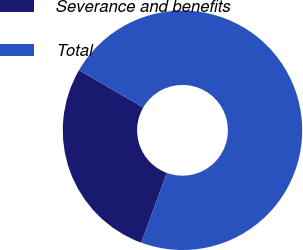Convert chart to OTSL. <chart><loc_0><loc_0><loc_500><loc_500><pie_chart><fcel>Severance and benefits<fcel>Total<nl><fcel>27.78%<fcel>72.22%<nl></chart> 